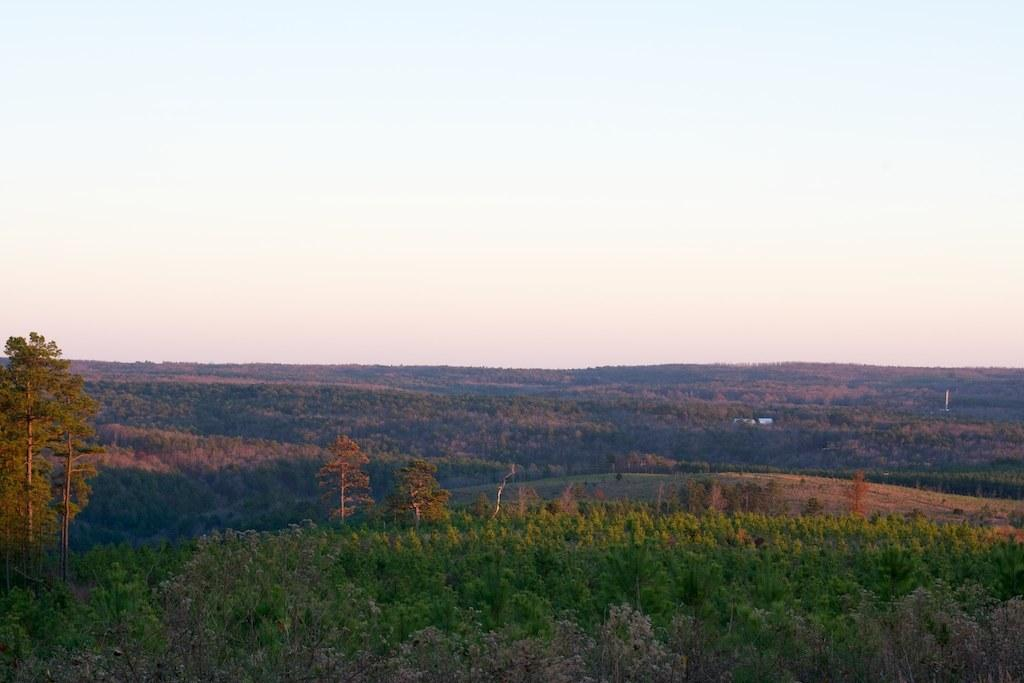What types of vegetation can be seen at the bottom of the image? There are many trees and plants at the bottom of the image. What can be seen in the background of the image? The sky is visible in the background of the image. What type of pie is being served in the image? There is no pie present in the image; it features trees and plants at the bottom and the sky in the background. 